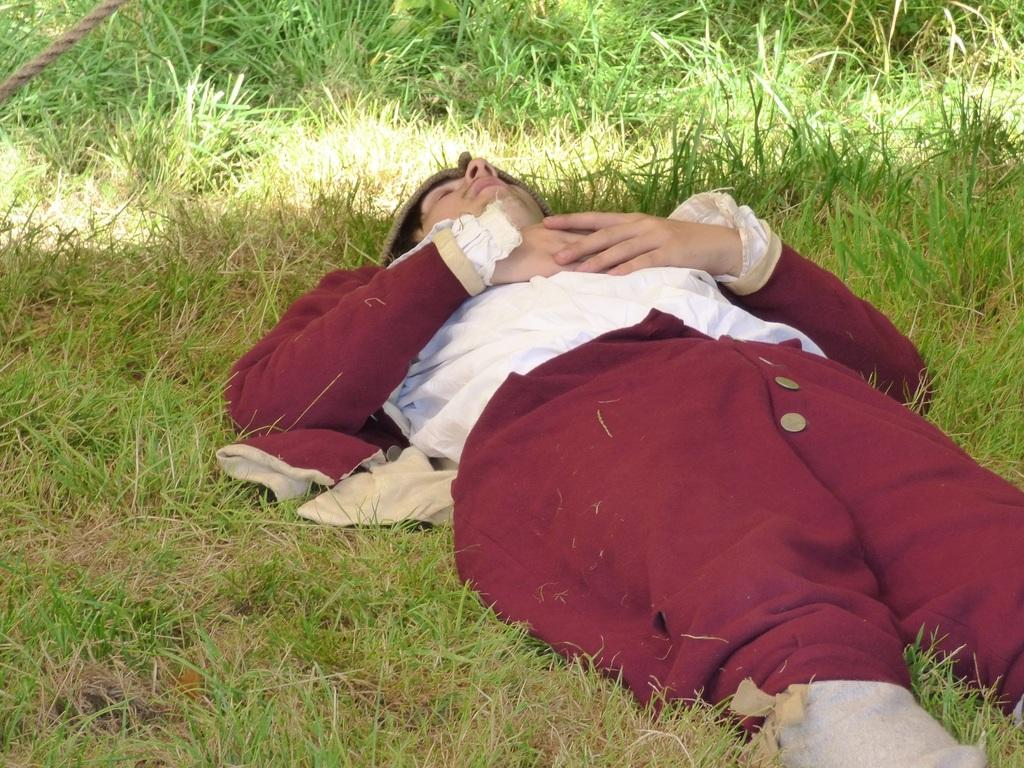What is the position of the man in the image? The man is lying on the ground in the image. What type of surface is the man lying on? There is grass visible in the image, so the man is likely lying on the grass. What can be seen at the top left side of the image? There appears to be a rope at the top left side of the image. What is the man wearing in the image? The man is wearing a fancy dress in the image. Can you hear the man whistling in the image? There is no indication of sound in the image, so we cannot determine if the man is whistling or not. How many frogs are hopping around the man in the image? There are no frogs present in the image. Is the man wearing a ring on his finger in the image? The image does not show the man's hands or fingers, so we cannot determine if he is wearing a ring or not. 